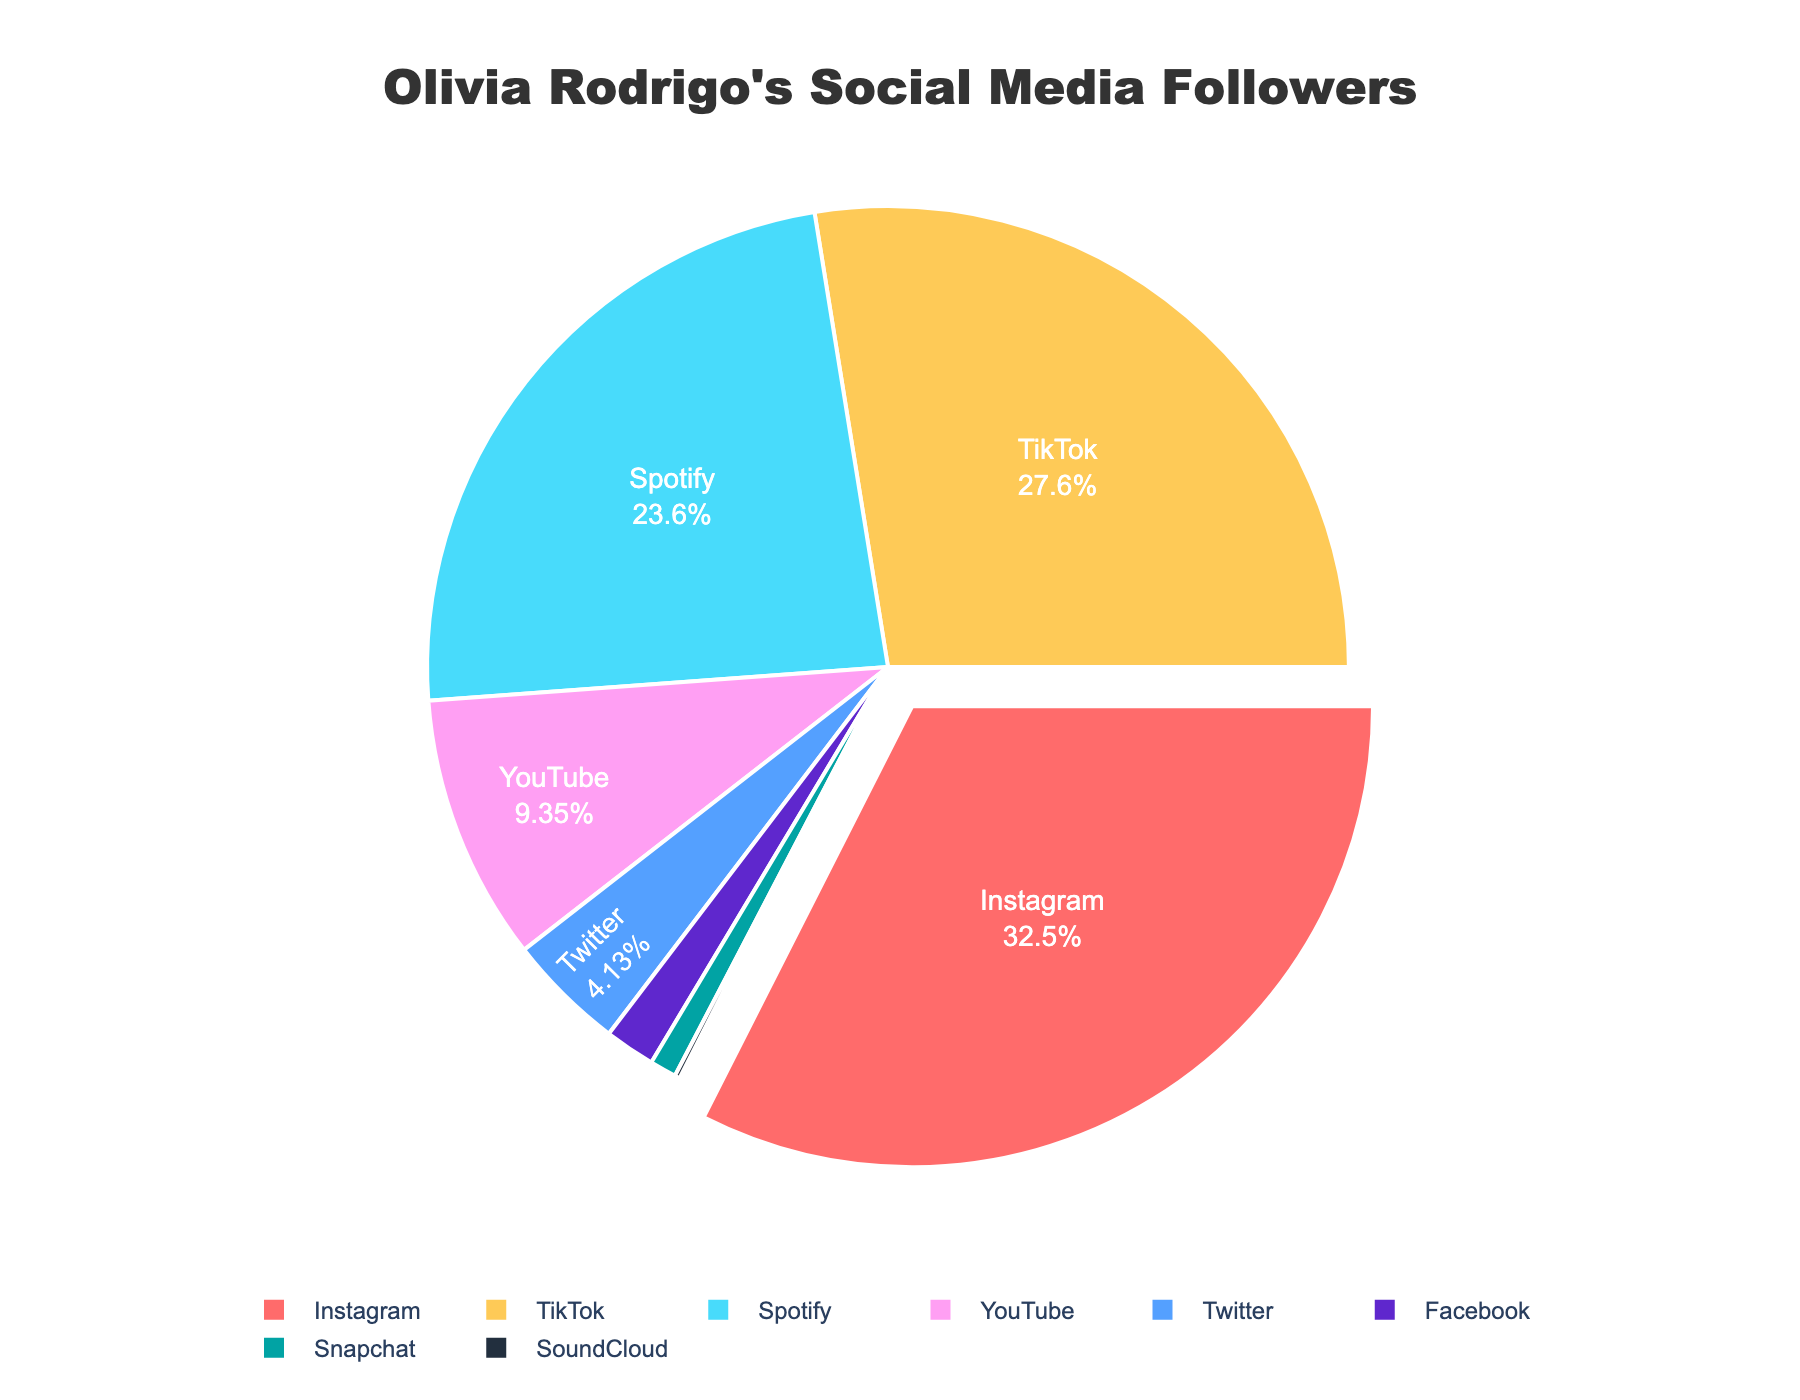What percentage of Olivia Rodrigo's followers are on Instagram? To find the percentage of followers on Instagram, look at the pie chart segment for Instagram. It shows Instagram's followers as a percentage of the total.
Answer: Approximately 33% Which platform has the second highest number of followers and what percentage do they represent? Determine which segment is the largest after Instagram. The segment for TikTok comes next, representing a specific percentage of the total followers.
Answer: TikTok with approximately 28% What is the combined percentage of followers on YouTube and Twitter? Calculate the percentage for YouTube and add it to the percentage for Twitter. YouTube's segment is around 9.5%, and Twitter's segment is about 4.2%. Adding these together gives the combined percentage.
Answer: Approximately 13.7% Out of Facebook and Snapchat, which platform has fewer followers and by how much? Compare the segment sizes for Facebook and Snapchat. Snapchat's followers are represented by a smaller segment compared to Facebook. The difference is the value attributed to Facebook minus the value attributed to Snapchat.
Answer: Snapchat has 850,000 fewer followers than Facebook What is the difference in percentage between Spotify and SoundCloud followers? Find the percentages for both Spotify and SoundCloud by looking at their respective segments. Subtract SoundCloud's percentage from Spotify's percentage.
Answer: Approximately 23.8% Which platform has the lowest number of followers and what percentage does it represent? Identify the smallest segment on the pie chart, which represents the platform with the fewest followers. This segment is for SoundCloud.
Answer: SoundCloud with approximately 0.18% How many more followers does TikTok have than YouTube? Find the number of followers for TikTok and for YouTube. Subtract the number of YouTube followers from the number of TikTok followers.
Answer: 18,500,000 more followers Compare the combined followers of Facebook and Snapchat to Olivia Rodrigo's followers on Twitter. Are they more or less? Add the followers from Facebook and Snapchat, then compare this sum to the number of Twitter followers. Check if the sum is greater or less than the Twitter followers.
Answer: Less Which platform is represented by the light blue color in the chart? Identify the platform corresponding to the color used in the chart's legend for light blue.
Answer: YouTube What percentage of followers does Twitter and Facebook together represent when combined? Add the percentages for Twitter (4.2%) and Facebook (1.8%) to find their combined percentage.
Answer: Approximately 6% 